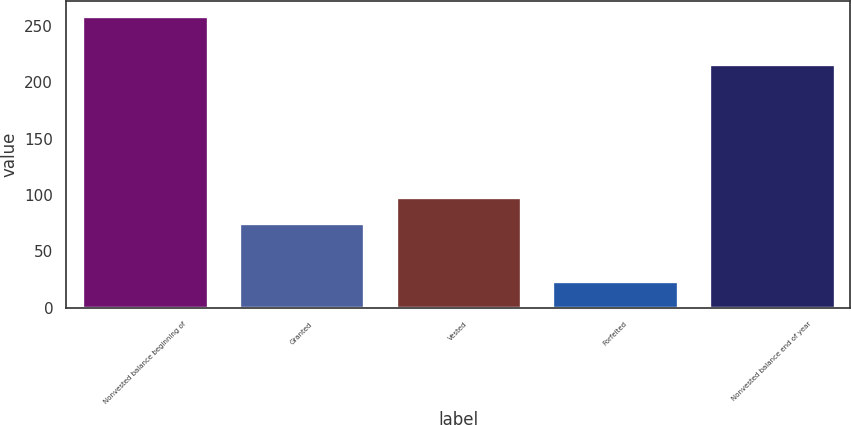Convert chart to OTSL. <chart><loc_0><loc_0><loc_500><loc_500><bar_chart><fcel>Nonvested balance beginning of<fcel>Granted<fcel>Vested<fcel>Forfeited<fcel>Nonvested balance end of year<nl><fcel>259<fcel>75<fcel>98.5<fcel>24<fcel>216<nl></chart> 